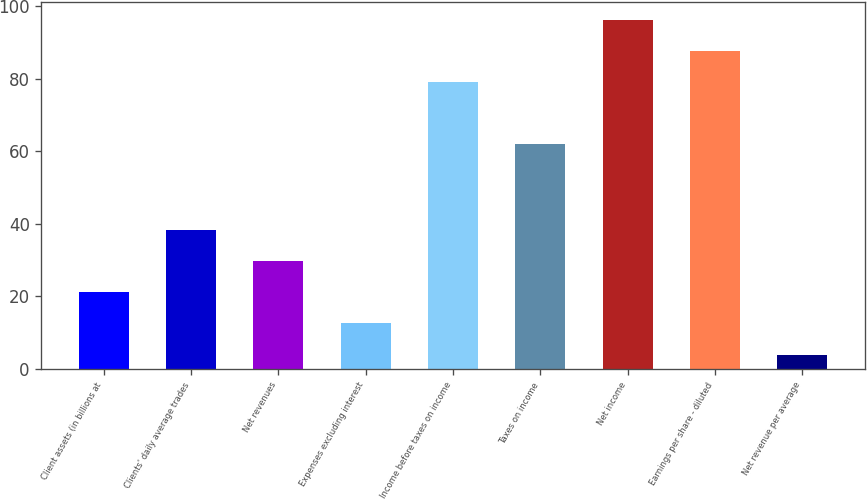Convert chart. <chart><loc_0><loc_0><loc_500><loc_500><bar_chart><fcel>Client assets (in billions at<fcel>Clients' daily average trades<fcel>Net revenues<fcel>Expenses excluding interest<fcel>Income before taxes on income<fcel>Taxes on income<fcel>Net income<fcel>Earnings per share - diluted<fcel>Net revenue per average<nl><fcel>21.2<fcel>38.4<fcel>29.8<fcel>12.6<fcel>79<fcel>62<fcel>96.2<fcel>87.6<fcel>4<nl></chart> 